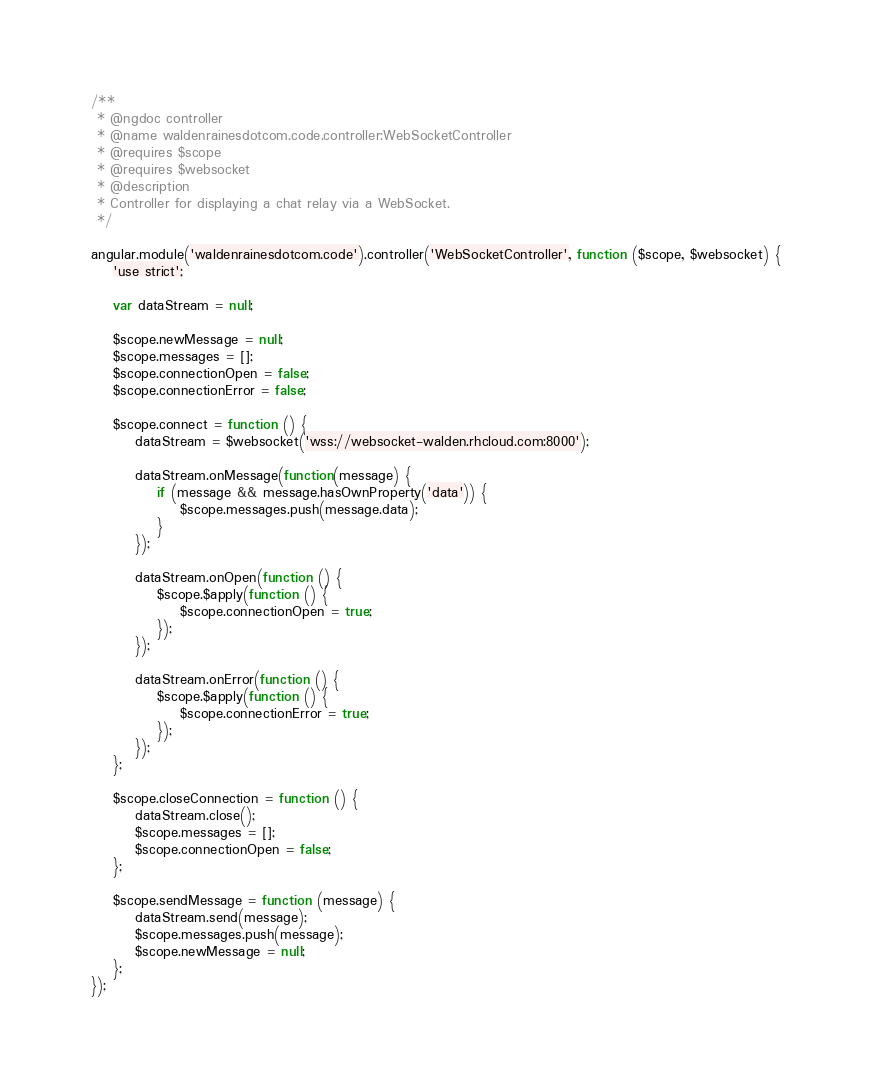Convert code to text. <code><loc_0><loc_0><loc_500><loc_500><_JavaScript_>/**
 * @ngdoc controller
 * @name waldenrainesdotcom.code.controller:WebSocketController
 * @requires $scope
 * @requires $websocket
 * @description
 * Controller for displaying a chat relay via a WebSocket.
 */

angular.module('waldenrainesdotcom.code').controller('WebSocketController', function ($scope, $websocket) {
    'use strict';

    var dataStream = null;

    $scope.newMessage = null;
    $scope.messages = [];
    $scope.connectionOpen = false;
    $scope.connectionError = false;

    $scope.connect = function () {
        dataStream = $websocket('wss://websocket-walden.rhcloud.com:8000');

        dataStream.onMessage(function(message) {
            if (message && message.hasOwnProperty('data')) {
                $scope.messages.push(message.data);
            }
        });

        dataStream.onOpen(function () {
            $scope.$apply(function () {
                $scope.connectionOpen = true;
            });
        });

        dataStream.onError(function () {
            $scope.$apply(function () {
                $scope.connectionError = true;
            });
        });
    };

    $scope.closeConnection = function () {
        dataStream.close();
        $scope.messages = [];
        $scope.connectionOpen = false;
    };

    $scope.sendMessage = function (message) {
        dataStream.send(message);
        $scope.messages.push(message);
        $scope.newMessage = null;
    };
});

</code> 